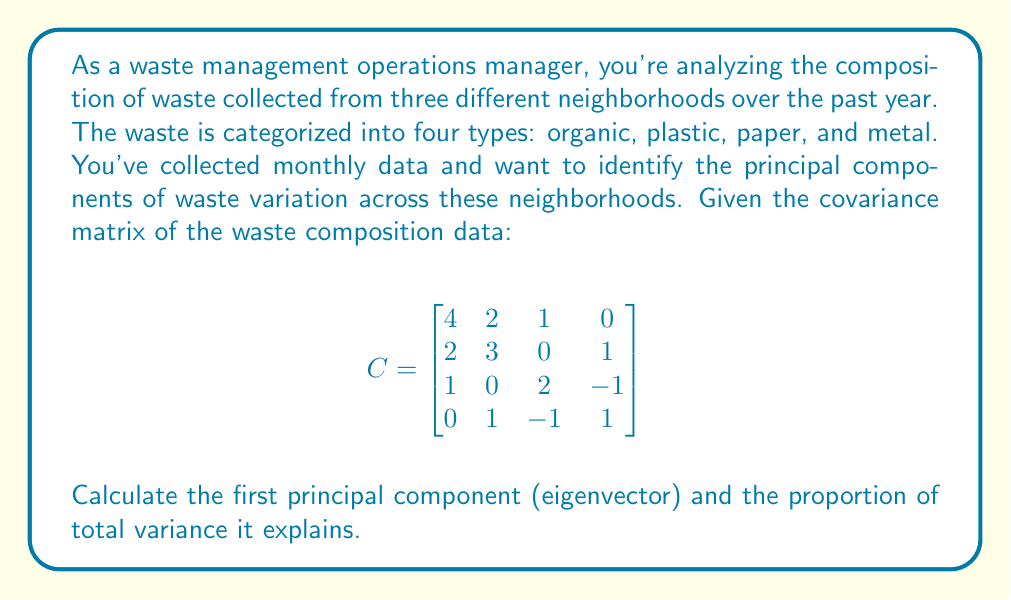Solve this math problem. To find the principal components and their explained variance, we need to follow these steps:

1) Find the eigenvalues and eigenvectors of the covariance matrix.
2) The eigenvector corresponding to the largest eigenvalue is the first principal component.
3) Calculate the proportion of variance explained by this component.

Step 1: Find eigenvalues
To find eigenvalues, solve the characteristic equation:
$\det(C - \lambda I) = 0$

$$\begin{vmatrix}
4-\lambda & 2 & 1 & 0 \\
2 & 3-\lambda & 0 & 1 \\
1 & 0 & 2-\lambda & -1 \\
0 & 1 & -1 & 1-\lambda
\end{vmatrix} = 0$$

Solving this equation (which is a 4th degree polynomial) gives us the eigenvalues:
$\lambda_1 \approx 5.30, \lambda_2 \approx 2.83, \lambda_3 \approx 1.52, \lambda_4 \approx 0.35$

Step 2: Find the first principal component (eigenvector for $\lambda_1$)
Solve $(C - \lambda_1 I)v = 0$ for $v$:

$$\begin{bmatrix}
-1.30 & 2 & 1 & 0 \\
2 & -2.30 & 0 & 1 \\
1 & 0 & -3.30 & -1 \\
0 & 1 & -1 & -4.30
\end{bmatrix} \begin{bmatrix} v_1 \\ v_2 \\ v_3 \\ v_4 \end{bmatrix} = \begin{bmatrix} 0 \\ 0 \\ 0 \\ 0 \end{bmatrix}$$

Solving this system and normalizing the result, we get the first principal component:
$v_1 \approx [0.65, 0.61, 0.32, 0.30]^T$

Step 3: Calculate the proportion of variance explained
The proportion of variance explained by the first principal component is:

$$\frac{\lambda_1}{\sum_{i=1}^4 \lambda_i} = \frac{5.30}{5.30 + 2.83 + 1.52 + 0.35} \approx 0.53$$

Therefore, the first principal component explains approximately 53% of the total variance in the waste composition data.
Answer: First principal component: $[0.65, 0.61, 0.32, 0.30]^T$, Variance explained: 53% 